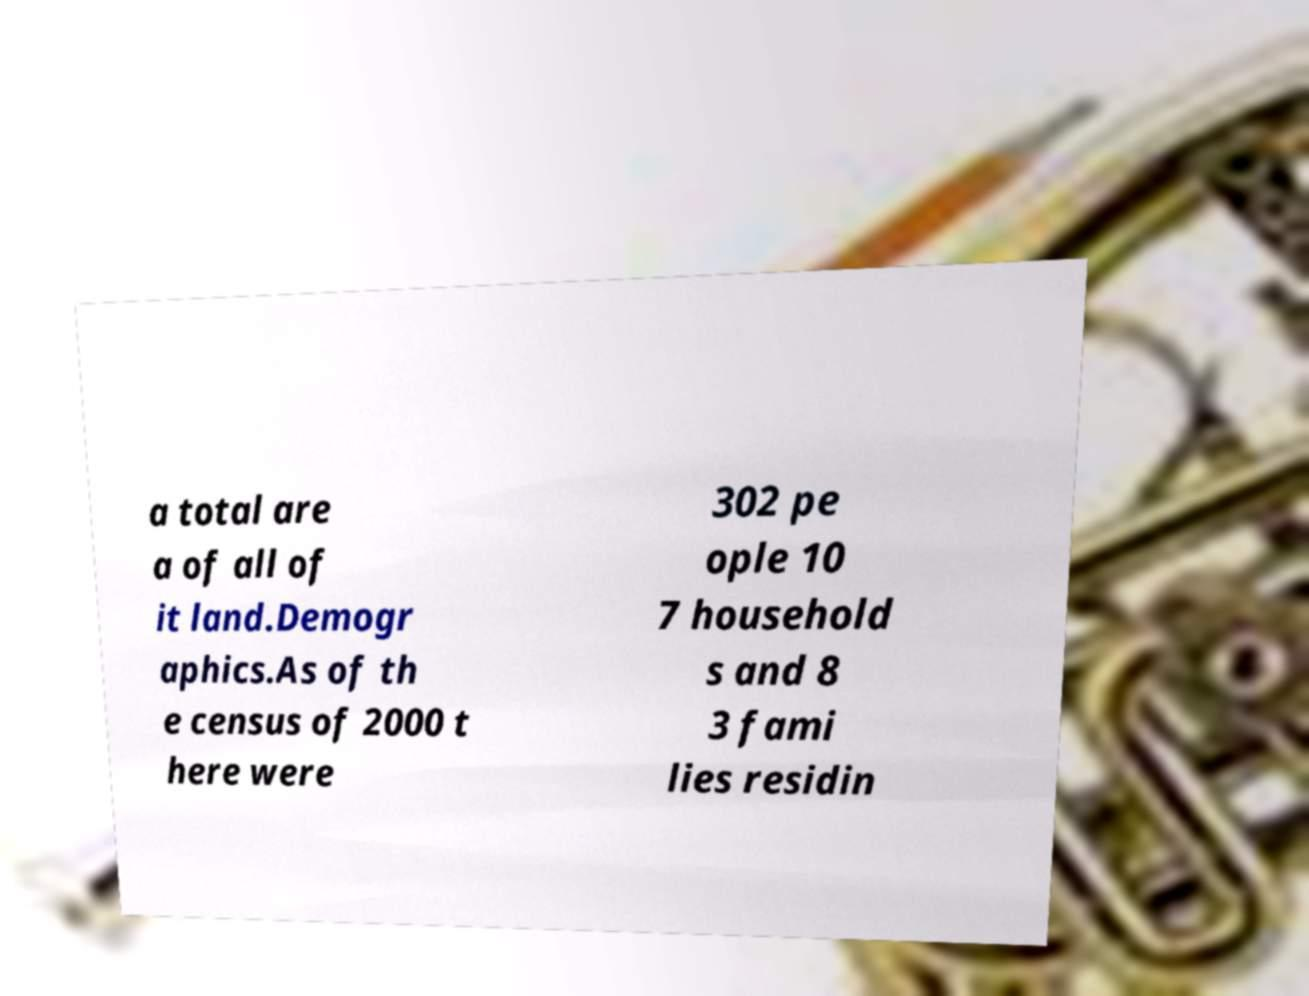There's text embedded in this image that I need extracted. Can you transcribe it verbatim? a total are a of all of it land.Demogr aphics.As of th e census of 2000 t here were 302 pe ople 10 7 household s and 8 3 fami lies residin 